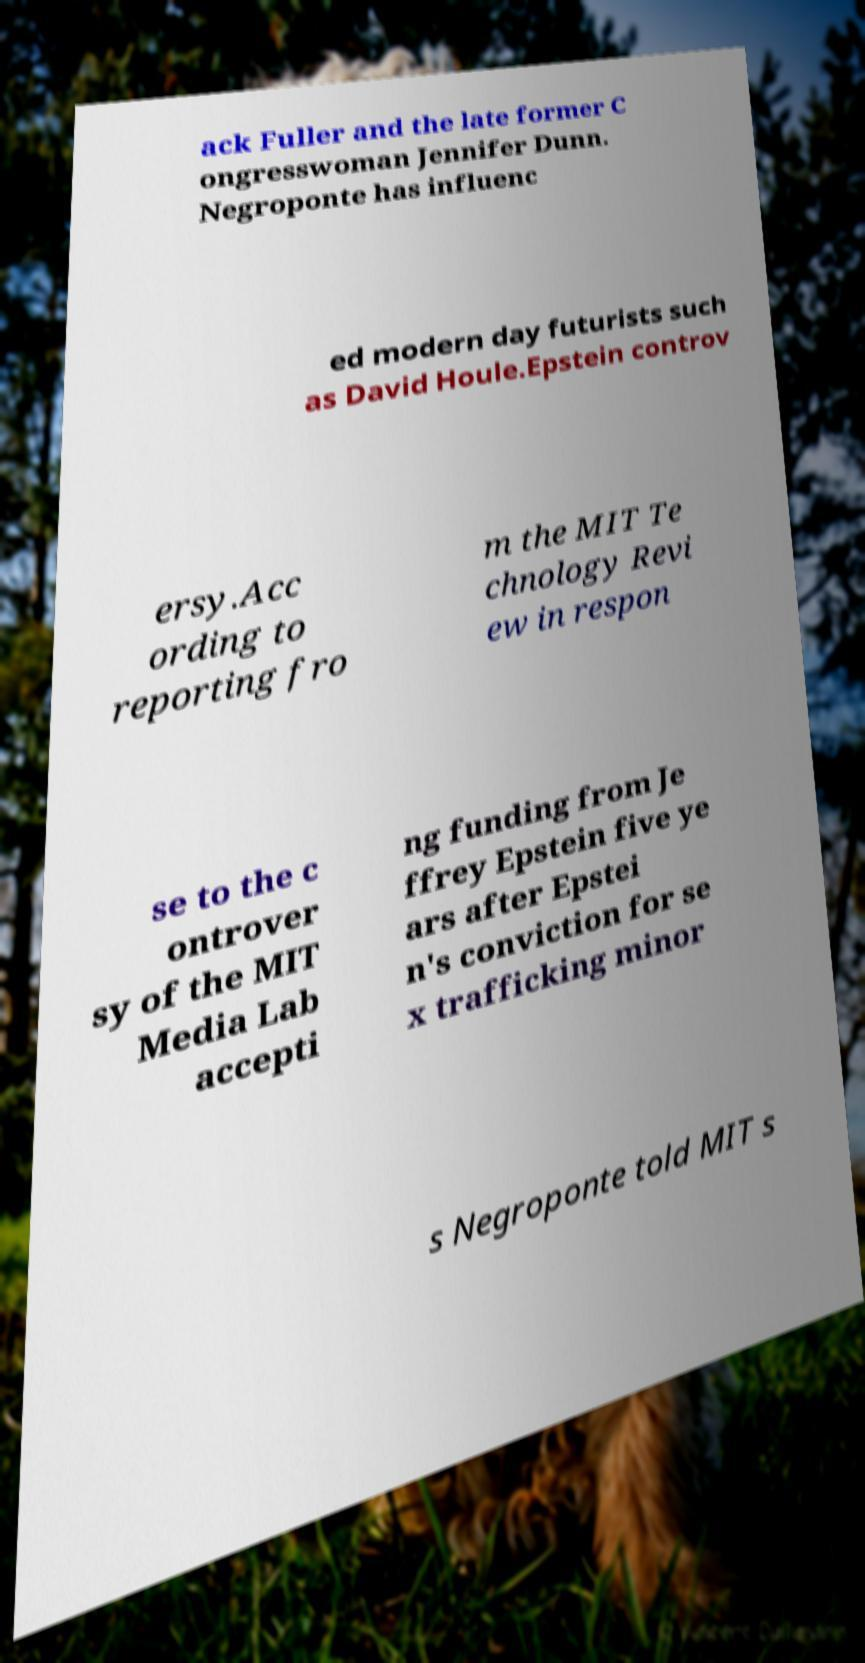Please read and relay the text visible in this image. What does it say? ack Fuller and the late former C ongresswoman Jennifer Dunn. Negroponte has influenc ed modern day futurists such as David Houle.Epstein controv ersy.Acc ording to reporting fro m the MIT Te chnology Revi ew in respon se to the c ontrover sy of the MIT Media Lab accepti ng funding from Je ffrey Epstein five ye ars after Epstei n's conviction for se x trafficking minor s Negroponte told MIT s 